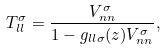<formula> <loc_0><loc_0><loc_500><loc_500>T _ { l l } ^ { \sigma } = \frac { V _ { n n } ^ { \sigma } } { 1 - g _ { l l \sigma } ( z ) V _ { n n } ^ { \sigma } } ,</formula> 